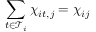Convert formula to latex. <formula><loc_0><loc_0><loc_500><loc_500>\sum _ { t \in \mathcal { T } _ { i } } \chi _ { i t , j } = \chi _ { i j }</formula> 